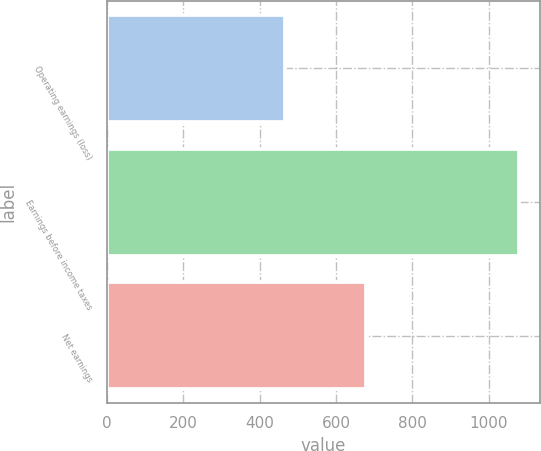<chart> <loc_0><loc_0><loc_500><loc_500><bar_chart><fcel>Operating earnings (loss)<fcel>Earnings before income taxes<fcel>Net earnings<nl><fcel>467.3<fcel>1079.4<fcel>678.5<nl></chart> 